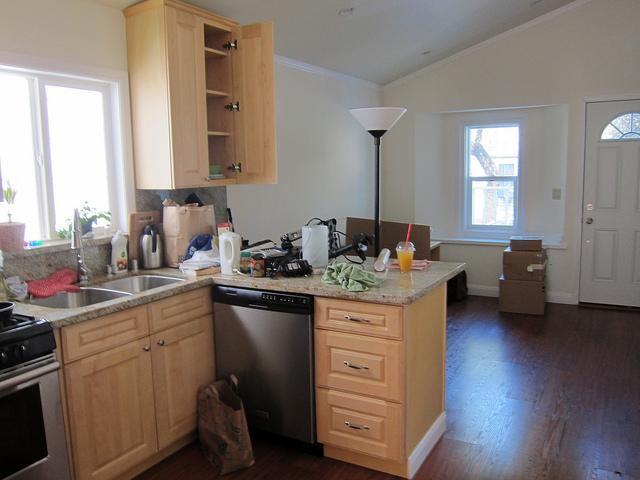How many windows do you see?
Give a very brief answer. 3. How many horses are going to pull this cart?
Give a very brief answer. 0. 